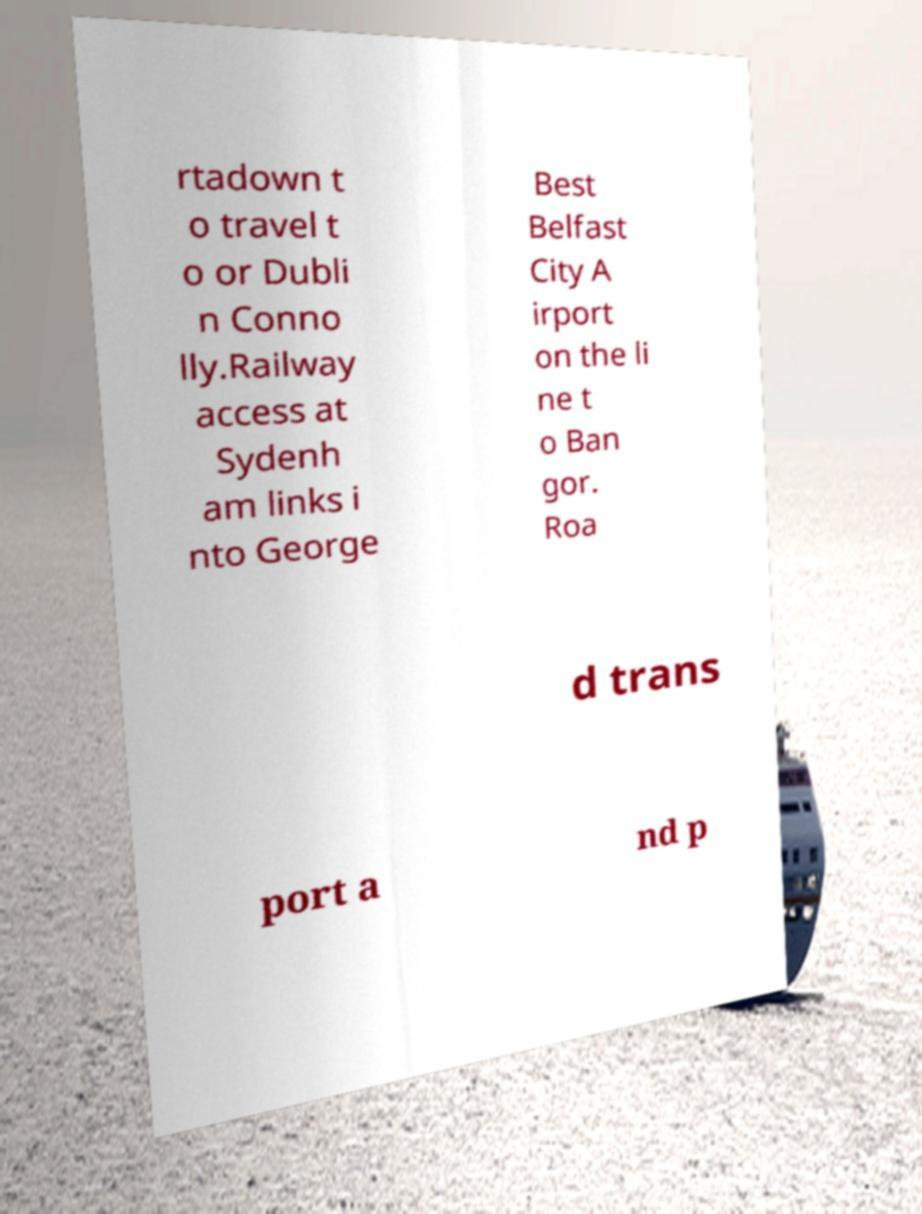Please read and relay the text visible in this image. What does it say? rtadown t o travel t o or Dubli n Conno lly.Railway access at Sydenh am links i nto George Best Belfast City A irport on the li ne t o Ban gor. Roa d trans port a nd p 